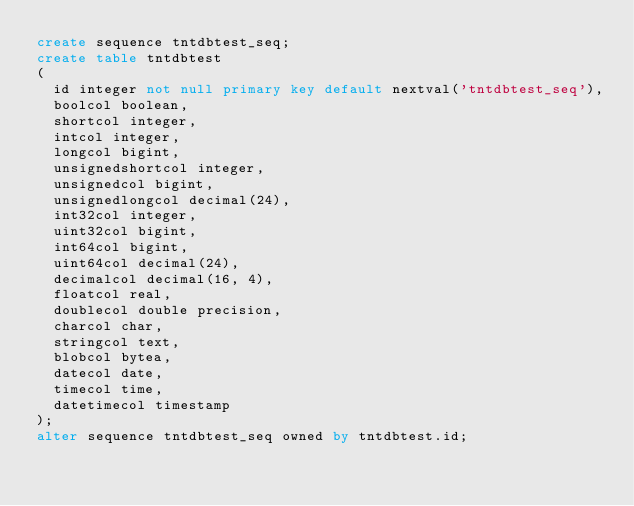Convert code to text. <code><loc_0><loc_0><loc_500><loc_500><_SQL_>create sequence tntdbtest_seq;
create table tntdbtest
(
  id integer not null primary key default nextval('tntdbtest_seq'),
  boolcol boolean,
  shortcol integer,
  intcol integer,
  longcol bigint,
  unsignedshortcol integer,
  unsignedcol bigint,
  unsignedlongcol decimal(24),
  int32col integer,
  uint32col bigint,
  int64col bigint,
  uint64col decimal(24),
  decimalcol decimal(16, 4),
  floatcol real,
  doublecol double precision,
  charcol char,
  stringcol text,
  blobcol bytea,
  datecol date,
  timecol time,
  datetimecol timestamp
);
alter sequence tntdbtest_seq owned by tntdbtest.id;
</code> 